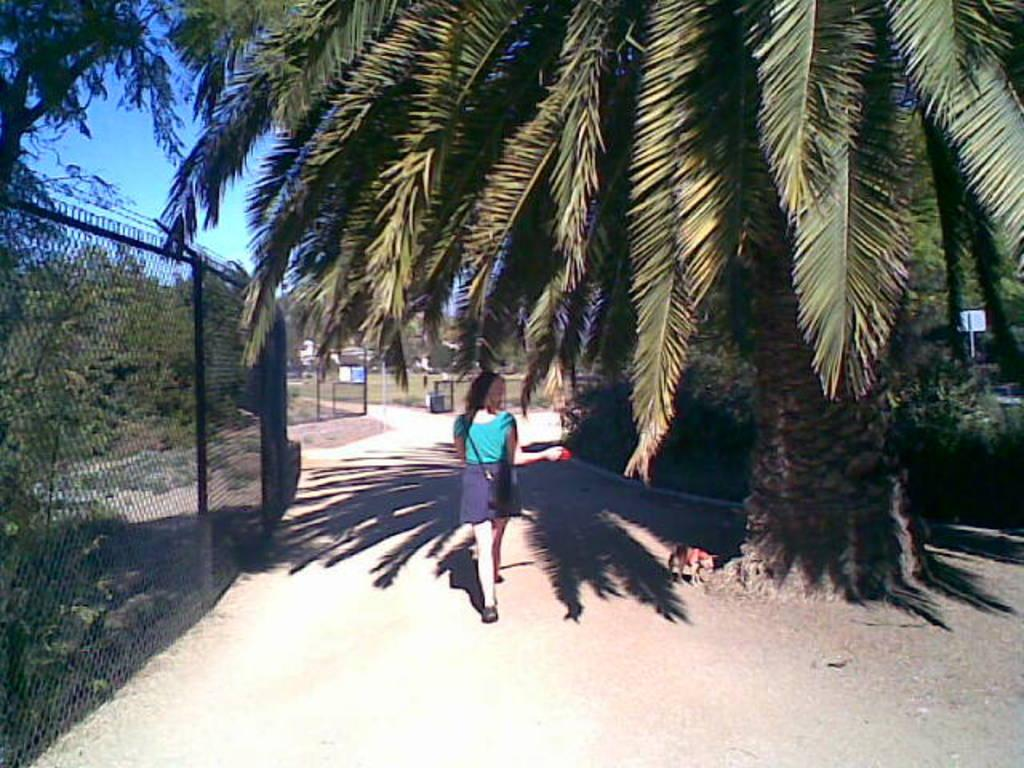What is the lady in the image doing? The lady in the image is walking. What animal is present in the image? There is a dog in the image. What can be seen on the left side of the image? There is a net boundary on the left side of the image. What is visible in the background of the image? There are trees, a boundary, and buildings in the background of the image. What type of property does the lady own in the image? There is no information about the lady owning any property in the image. 